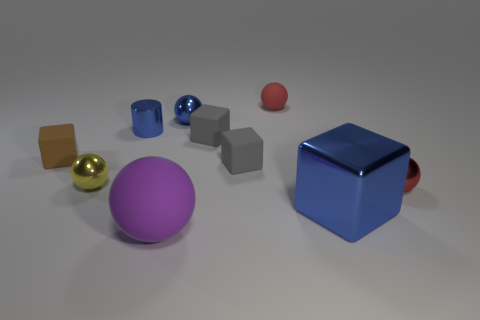What is the size of the brown object that is the same shape as the big blue metal thing?
Provide a short and direct response. Small. There is a tiny red thing in front of the red object to the left of the small red metal object; what number of matte things are behind it?
Your response must be concise. 4. Are there the same number of large spheres behind the big purple matte object and small yellow matte cylinders?
Your response must be concise. Yes. What number of spheres are gray things or small red things?
Offer a terse response. 2. Do the large shiny object and the shiny cylinder have the same color?
Make the answer very short. Yes. Are there the same number of blue objects that are left of the blue cylinder and gray cubes that are in front of the tiny red rubber thing?
Your answer should be compact. No. What color is the large cube?
Keep it short and to the point. Blue. What number of things are either small red balls that are in front of the small matte ball or cubes?
Keep it short and to the point. 5. Do the gray cube behind the brown rubber cube and the blue shiny thing that is right of the tiny matte sphere have the same size?
Your response must be concise. No. What number of things are either matte objects that are behind the tiny brown cube or small matte balls behind the yellow object?
Provide a short and direct response. 2. 